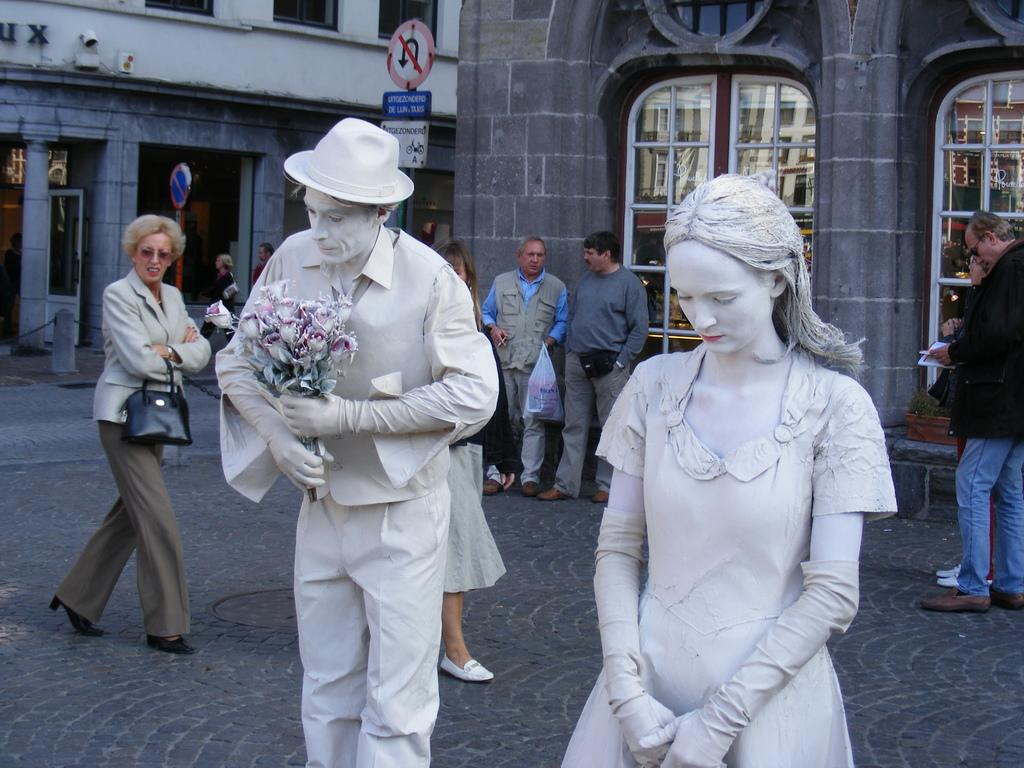What are the people in the image doing? The people in the image are standing and walking. What can be seen in the distance behind the people? There are buildings visible in the background. What else can be seen in the background? There are poles and sign boards present in the background. How many elbows can be seen on the people in the image? It is impossible to determine the number of elbows visible on the people in the image, as the positioning of their arms is not clear. 